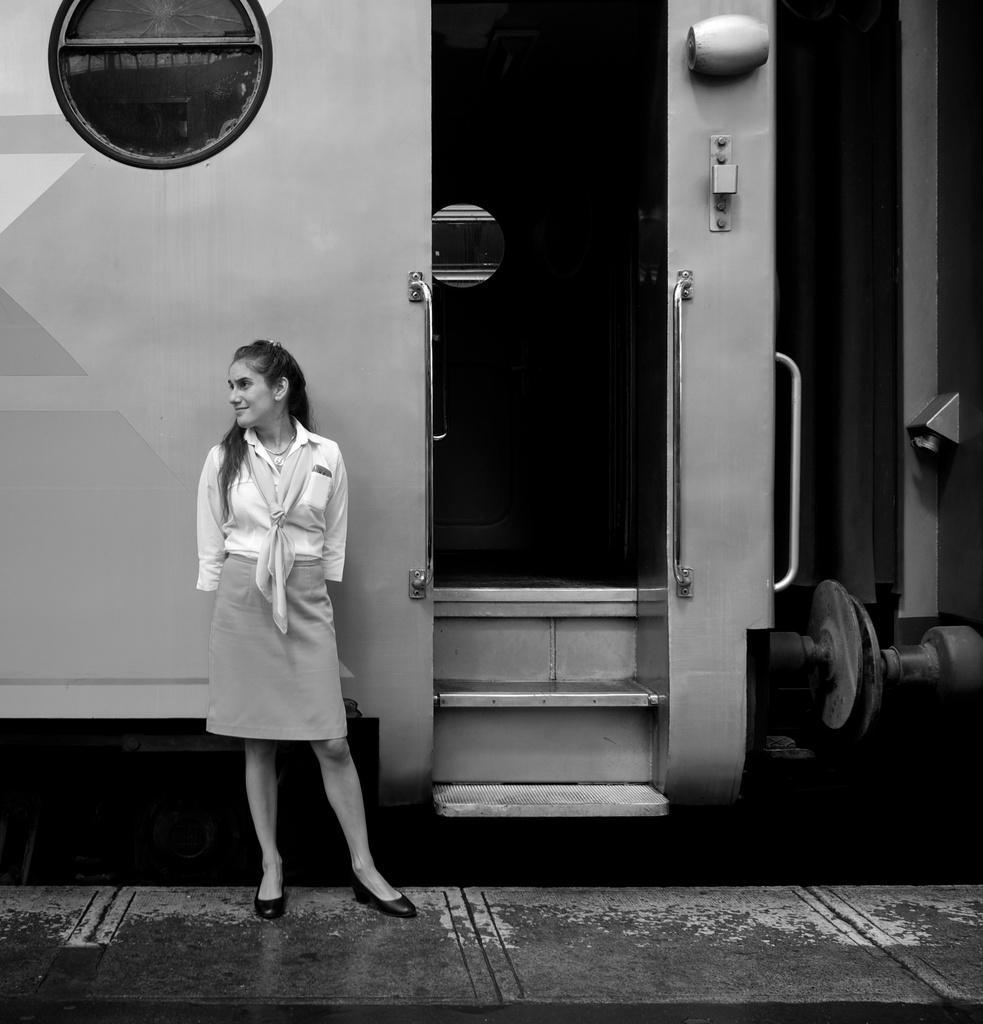Could you give a brief overview of what you see in this image? This is a black and white image. Here I can see a woman standing on the platform and smiling by looking at the left side. At the back of her there is a train. 